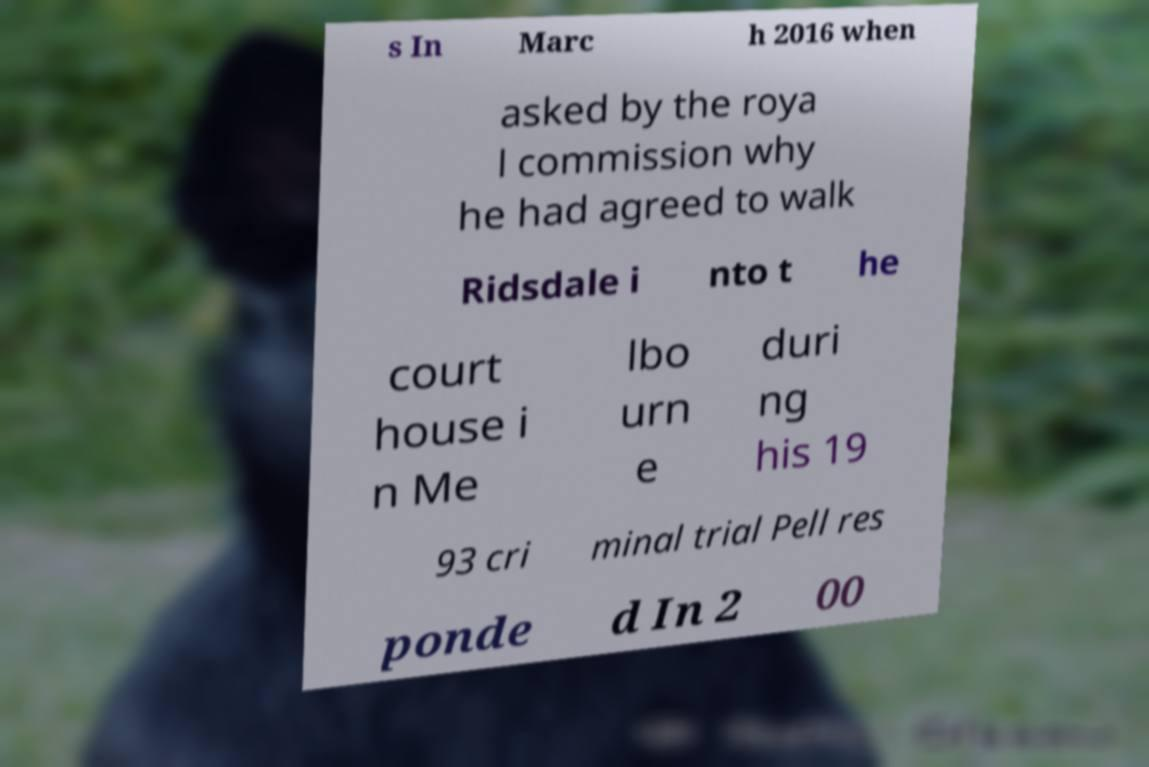There's text embedded in this image that I need extracted. Can you transcribe it verbatim? s In Marc h 2016 when asked by the roya l commission why he had agreed to walk Ridsdale i nto t he court house i n Me lbo urn e duri ng his 19 93 cri minal trial Pell res ponde d In 2 00 